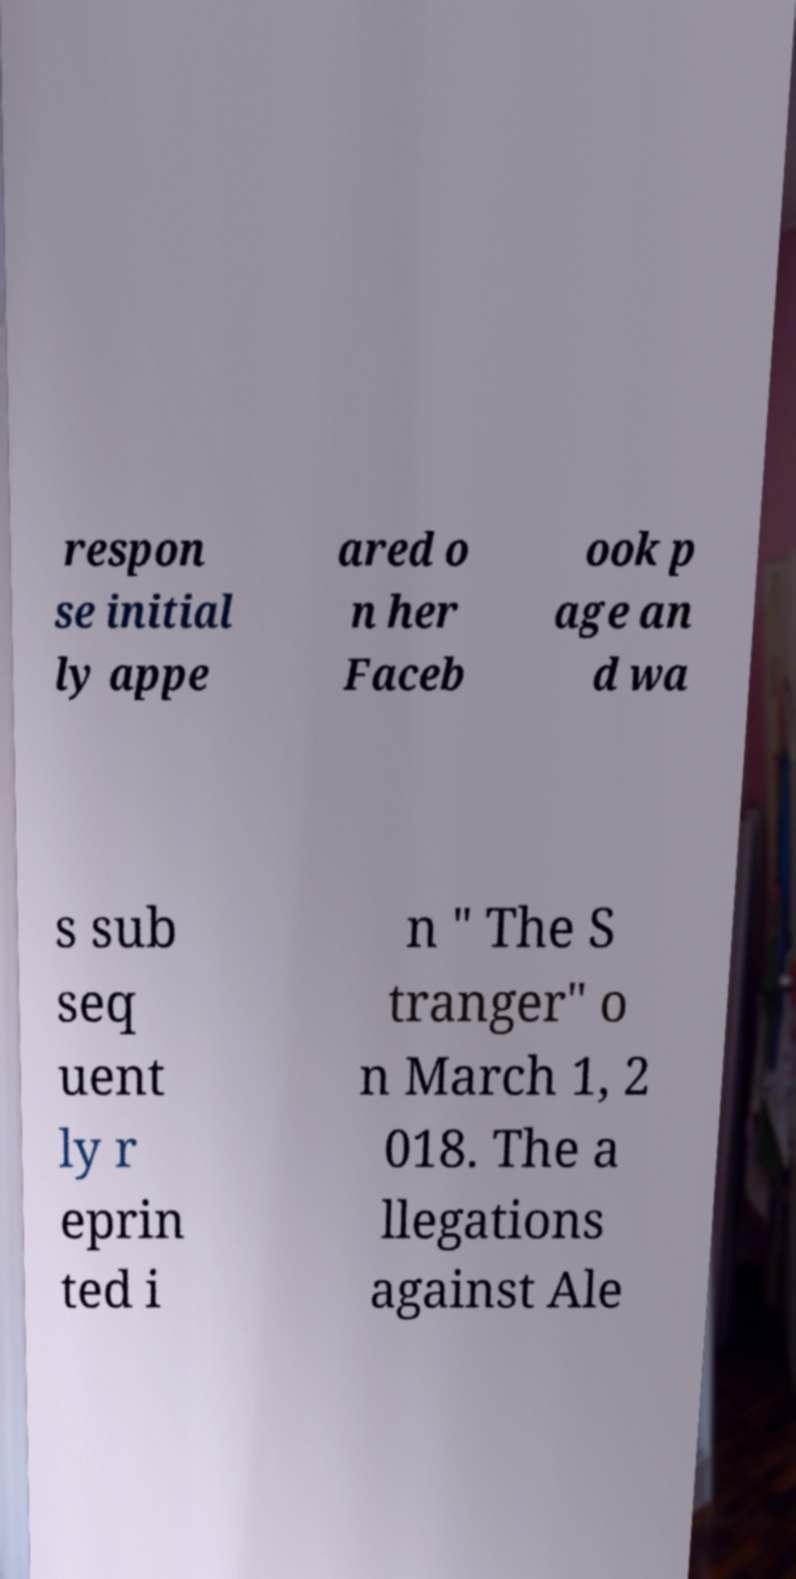There's text embedded in this image that I need extracted. Can you transcribe it verbatim? respon se initial ly appe ared o n her Faceb ook p age an d wa s sub seq uent ly r eprin ted i n " The S tranger" o n March 1, 2 018. The a llegations against Ale 